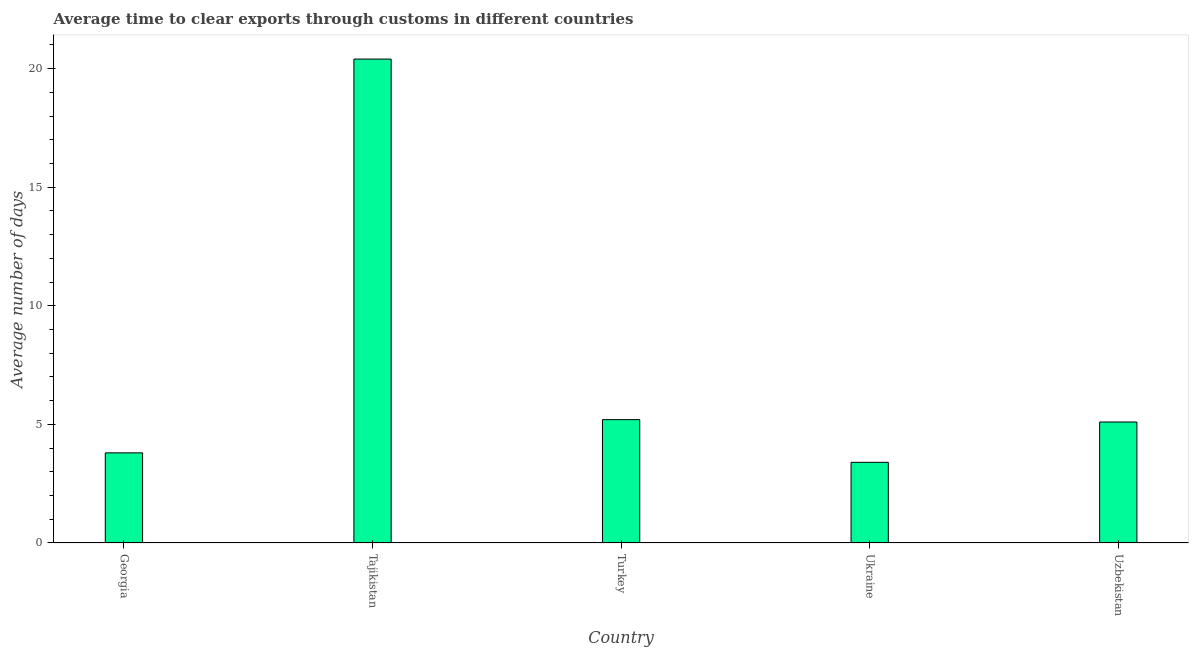Does the graph contain any zero values?
Your answer should be very brief. No. Does the graph contain grids?
Your answer should be very brief. No. What is the title of the graph?
Give a very brief answer. Average time to clear exports through customs in different countries. What is the label or title of the Y-axis?
Offer a very short reply. Average number of days. Across all countries, what is the maximum time to clear exports through customs?
Your response must be concise. 20.4. Across all countries, what is the minimum time to clear exports through customs?
Provide a short and direct response. 3.4. In which country was the time to clear exports through customs maximum?
Your answer should be very brief. Tajikistan. In which country was the time to clear exports through customs minimum?
Offer a very short reply. Ukraine. What is the sum of the time to clear exports through customs?
Make the answer very short. 37.9. What is the difference between the time to clear exports through customs in Tajikistan and Turkey?
Ensure brevity in your answer.  15.2. What is the average time to clear exports through customs per country?
Your answer should be compact. 7.58. What is the ratio of the time to clear exports through customs in Tajikistan to that in Turkey?
Your answer should be compact. 3.92. Is the time to clear exports through customs in Georgia less than that in Tajikistan?
Give a very brief answer. Yes. Is the sum of the time to clear exports through customs in Georgia and Uzbekistan greater than the maximum time to clear exports through customs across all countries?
Offer a terse response. No. What is the difference between the highest and the lowest time to clear exports through customs?
Provide a short and direct response. 17. In how many countries, is the time to clear exports through customs greater than the average time to clear exports through customs taken over all countries?
Your response must be concise. 1. What is the difference between two consecutive major ticks on the Y-axis?
Your response must be concise. 5. Are the values on the major ticks of Y-axis written in scientific E-notation?
Your answer should be compact. No. What is the Average number of days of Tajikistan?
Offer a terse response. 20.4. What is the difference between the Average number of days in Georgia and Tajikistan?
Give a very brief answer. -16.6. What is the difference between the Average number of days in Georgia and Turkey?
Give a very brief answer. -1.4. What is the difference between the Average number of days in Georgia and Ukraine?
Offer a very short reply. 0.4. What is the difference between the Average number of days in Georgia and Uzbekistan?
Your response must be concise. -1.3. What is the difference between the Average number of days in Turkey and Ukraine?
Your answer should be very brief. 1.8. What is the difference between the Average number of days in Turkey and Uzbekistan?
Provide a succinct answer. 0.1. What is the difference between the Average number of days in Ukraine and Uzbekistan?
Offer a terse response. -1.7. What is the ratio of the Average number of days in Georgia to that in Tajikistan?
Ensure brevity in your answer.  0.19. What is the ratio of the Average number of days in Georgia to that in Turkey?
Provide a succinct answer. 0.73. What is the ratio of the Average number of days in Georgia to that in Ukraine?
Keep it short and to the point. 1.12. What is the ratio of the Average number of days in Georgia to that in Uzbekistan?
Provide a short and direct response. 0.74. What is the ratio of the Average number of days in Tajikistan to that in Turkey?
Offer a very short reply. 3.92. What is the ratio of the Average number of days in Turkey to that in Ukraine?
Provide a succinct answer. 1.53. What is the ratio of the Average number of days in Turkey to that in Uzbekistan?
Your response must be concise. 1.02. What is the ratio of the Average number of days in Ukraine to that in Uzbekistan?
Ensure brevity in your answer.  0.67. 